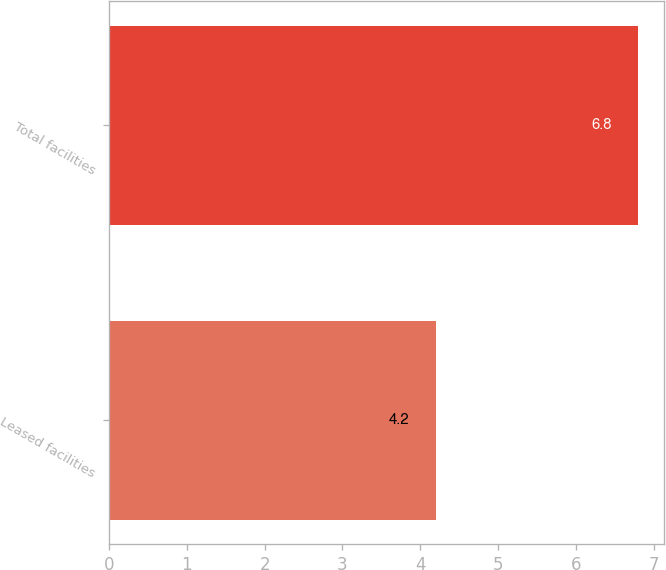<chart> <loc_0><loc_0><loc_500><loc_500><bar_chart><fcel>Leased facilities<fcel>Total facilities<nl><fcel>4.2<fcel>6.8<nl></chart> 